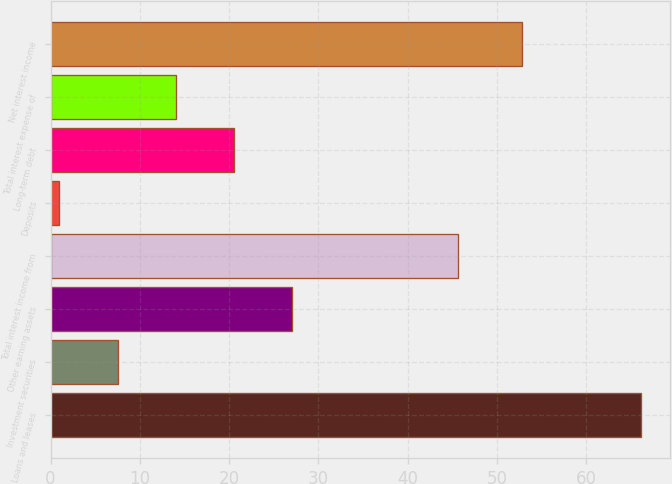<chart> <loc_0><loc_0><loc_500><loc_500><bar_chart><fcel>Loans and leases<fcel>Investment securities<fcel>Other earning assets<fcel>Total interest income from<fcel>Deposits<fcel>Long-term debt<fcel>Total interest expense of<fcel>Net interest income<nl><fcel>66.1<fcel>7.51<fcel>27.04<fcel>45.6<fcel>1<fcel>20.53<fcel>14.02<fcel>52.8<nl></chart> 